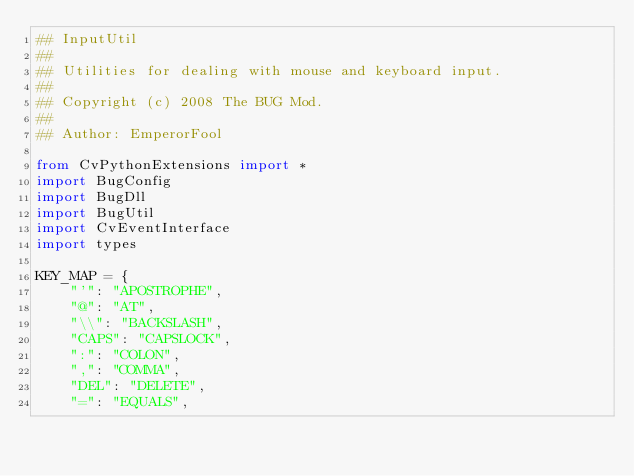<code> <loc_0><loc_0><loc_500><loc_500><_Python_>## InputUtil
##
## Utilities for dealing with mouse and keyboard input.
##
## Copyright (c) 2008 The BUG Mod.
##
## Author: EmperorFool

from CvPythonExtensions import *
import BugConfig
import BugDll
import BugUtil
import CvEventInterface
import types

KEY_MAP = {
	"'": "APOSTROPHE",
	"@": "AT",
	"\\": "BACKSLASH",
	"CAPS": "CAPSLOCK",
	":": "COLON",
	",": "COMMA",
	"DEL": "DELETE",
	"=": "EQUALS",</code> 